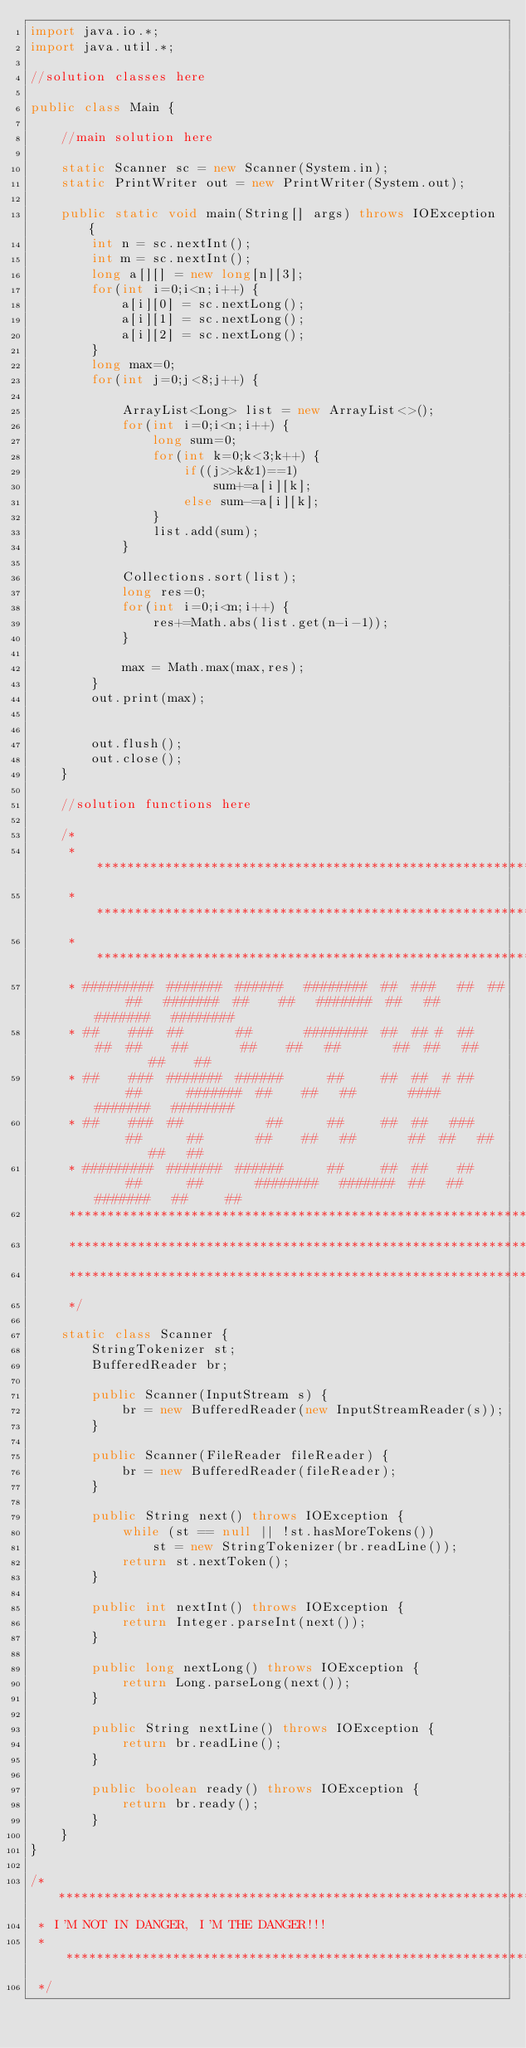<code> <loc_0><loc_0><loc_500><loc_500><_Java_>import java.io.*;
import java.util.*;

//solution classes here

public class Main {

    //main solution here

    static Scanner sc = new Scanner(System.in);
    static PrintWriter out = new PrintWriter(System.out);

    public static void main(String[] args) throws IOException {
        int n = sc.nextInt();
        int m = sc.nextInt();
        long a[][] = new long[n][3];
        for(int i=0;i<n;i++) {
            a[i][0] = sc.nextLong();
            a[i][1] = sc.nextLong();
            a[i][2] = sc.nextLong();
        }
        long max=0;
        for(int j=0;j<8;j++) {

            ArrayList<Long> list = new ArrayList<>();
            for(int i=0;i<n;i++) {
                long sum=0;
                for(int k=0;k<3;k++) {
                    if((j>>k&1)==1)
                        sum+=a[i][k];
                    else sum-=a[i][k];
                }
                list.add(sum);
            }

            Collections.sort(list);
            long res=0;
            for(int i=0;i<m;i++) {
                res+=Math.abs(list.get(n-i-1));
            }

            max = Math.max(max,res);
        }
        out.print(max);


        out.flush();
        out.close();
    }

    //solution functions here

    /*
     * ******************************************************************************************************************************
     * ******************************************************************************************************************************
     * ******************************************************************************************************************************
     * #########  #######  ######   ########  ##  ###   ##  ##    ##   #######  ##    ##   #######  ##   ##  #######   ########
     * ##    ###  ##       ##       ########  ##  ## #  ##   ##  ##    ##       ##    ##   ##       ##  ##   ##        ##    ##
     * ##    ###  #######  ######      ##     ##  ##  # ##     ##      #######  ##    ##   ##       ####     #######   ########
     * ##    ###  ##           ##      ##     ##  ##   ###     ##      ##       ##    ##   ##       ##  ##   ##        ##   ##
     * #########  #######  ######      ##     ##  ##    ##     ##      ##       ########   #######  ##   ##  #######   ##     ##
     *******************************************************************************************************************************
     *******************************************************************************************************************************
     *******************************************************************************************************************************
     */

    static class Scanner {
        StringTokenizer st;
        BufferedReader br;

        public Scanner(InputStream s) {
            br = new BufferedReader(new InputStreamReader(s));
        }

        public Scanner(FileReader fileReader) {
            br = new BufferedReader(fileReader);
        }

        public String next() throws IOException {
            while (st == null || !st.hasMoreTokens())
                st = new StringTokenizer(br.readLine());
            return st.nextToken();
        }

        public int nextInt() throws IOException {
            return Integer.parseInt(next());
        }

        public long nextLong() throws IOException {
            return Long.parseLong(next());
        }

        public String nextLine() throws IOException {
            return br.readLine();
        }

        public boolean ready() throws IOException {
            return br.ready();
        }
    }
}

/* *****************************************************************************************************************************
 * I'M NOT IN DANGER, I'M THE DANGER!!!
 * *****************************************************************************************************************************
 */</code> 